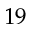<formula> <loc_0><loc_0><loc_500><loc_500>1 9</formula> 